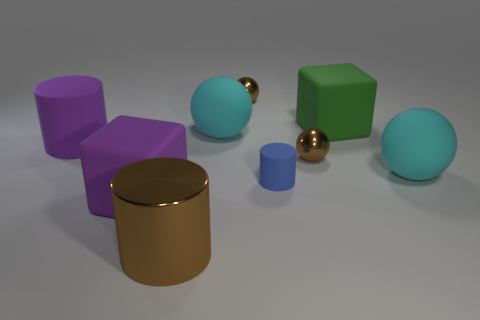Subtract all cylinders. How many objects are left? 6 Subtract 0 yellow cylinders. How many objects are left? 9 Subtract all tiny metal objects. Subtract all cyan rubber things. How many objects are left? 5 Add 6 purple matte things. How many purple matte things are left? 8 Add 2 purple matte things. How many purple matte things exist? 4 